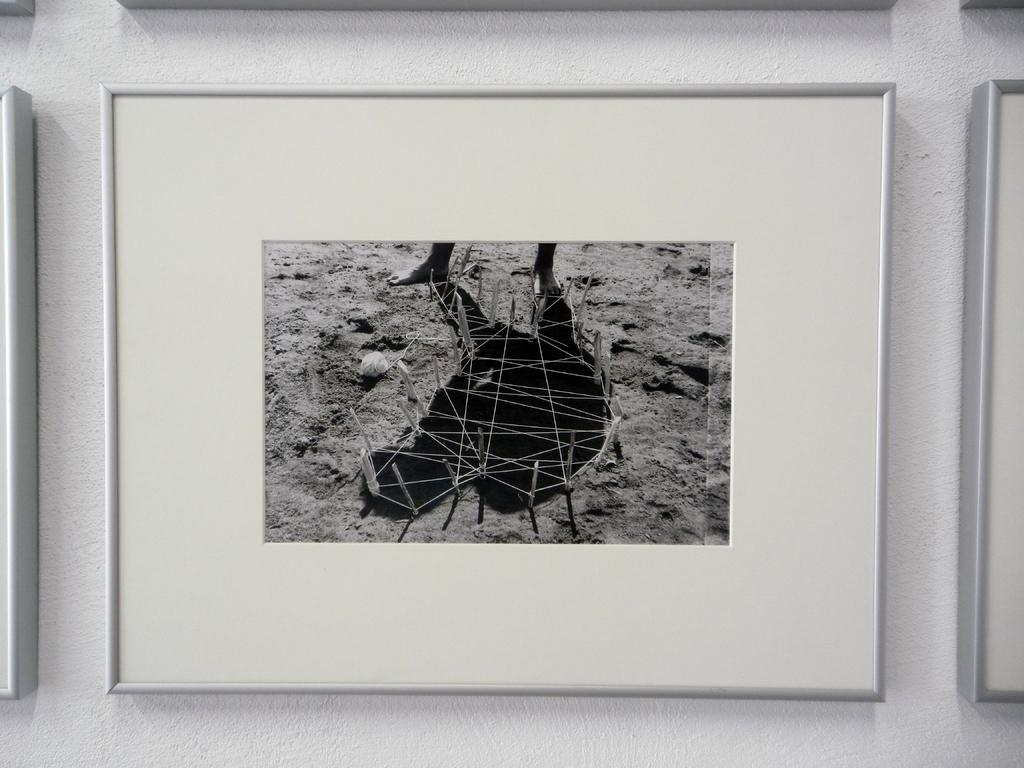What type of artwork can be seen in the image? There are wall paintings in the image. Can you describe the setting where the wall paintings are located? The image may have been taken in a room. Is there a page from a book being used as a skateboard in the image? There is no page from a book or any skateboard present in the image. 